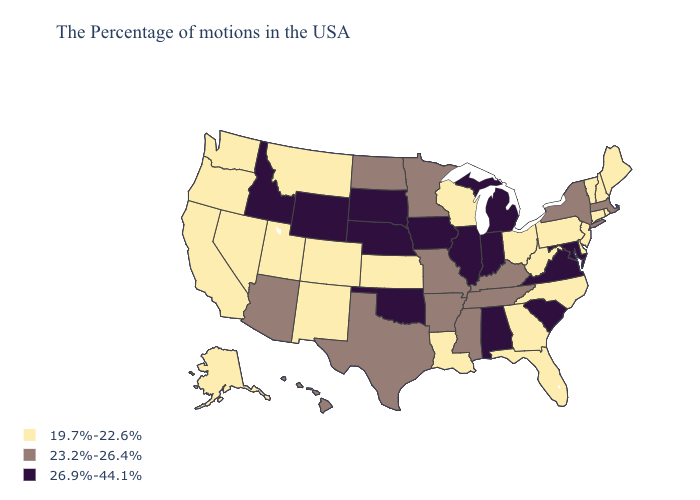What is the highest value in states that border New York?
Short answer required. 23.2%-26.4%. Which states have the lowest value in the USA?
Be succinct. Maine, Rhode Island, New Hampshire, Vermont, Connecticut, New Jersey, Delaware, Pennsylvania, North Carolina, West Virginia, Ohio, Florida, Georgia, Wisconsin, Louisiana, Kansas, Colorado, New Mexico, Utah, Montana, Nevada, California, Washington, Oregon, Alaska. Does North Dakota have the same value as New Hampshire?
Be succinct. No. Among the states that border South Carolina , which have the lowest value?
Concise answer only. North Carolina, Georgia. What is the value of Virginia?
Write a very short answer. 26.9%-44.1%. Name the states that have a value in the range 19.7%-22.6%?
Quick response, please. Maine, Rhode Island, New Hampshire, Vermont, Connecticut, New Jersey, Delaware, Pennsylvania, North Carolina, West Virginia, Ohio, Florida, Georgia, Wisconsin, Louisiana, Kansas, Colorado, New Mexico, Utah, Montana, Nevada, California, Washington, Oregon, Alaska. Does the map have missing data?
Concise answer only. No. What is the value of Delaware?
Short answer required. 19.7%-22.6%. Does New York have the same value as Arkansas?
Write a very short answer. Yes. Does New York have the highest value in the USA?
Short answer required. No. Which states have the lowest value in the MidWest?
Concise answer only. Ohio, Wisconsin, Kansas. What is the value of Idaho?
Quick response, please. 26.9%-44.1%. What is the value of South Dakota?
Write a very short answer. 26.9%-44.1%. Name the states that have a value in the range 23.2%-26.4%?
Short answer required. Massachusetts, New York, Kentucky, Tennessee, Mississippi, Missouri, Arkansas, Minnesota, Texas, North Dakota, Arizona, Hawaii. 